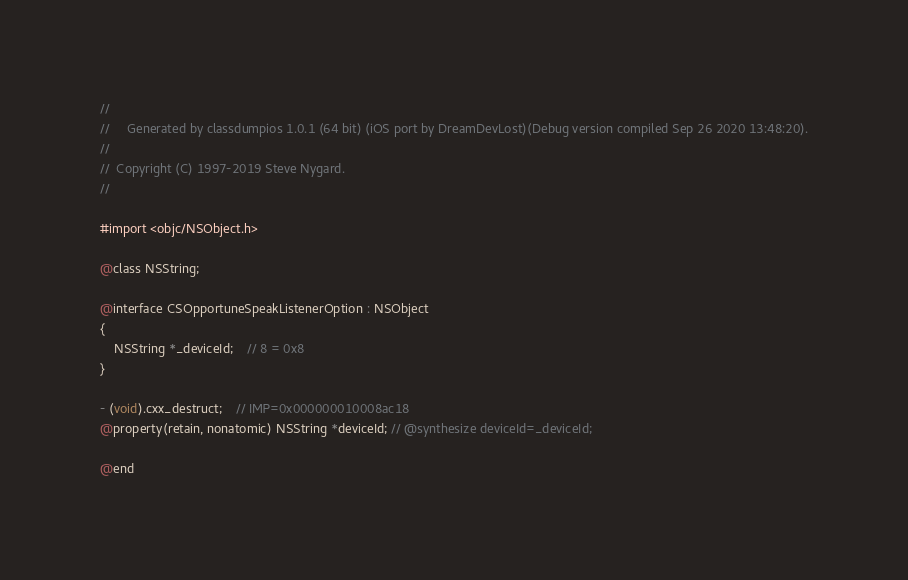<code> <loc_0><loc_0><loc_500><loc_500><_C_>//
//     Generated by classdumpios 1.0.1 (64 bit) (iOS port by DreamDevLost)(Debug version compiled Sep 26 2020 13:48:20).
//
//  Copyright (C) 1997-2019 Steve Nygard.
//

#import <objc/NSObject.h>

@class NSString;

@interface CSOpportuneSpeakListenerOption : NSObject
{
    NSString *_deviceId;	// 8 = 0x8
}

- (void).cxx_destruct;	// IMP=0x000000010008ac18
@property(retain, nonatomic) NSString *deviceId; // @synthesize deviceId=_deviceId;

@end

</code> 